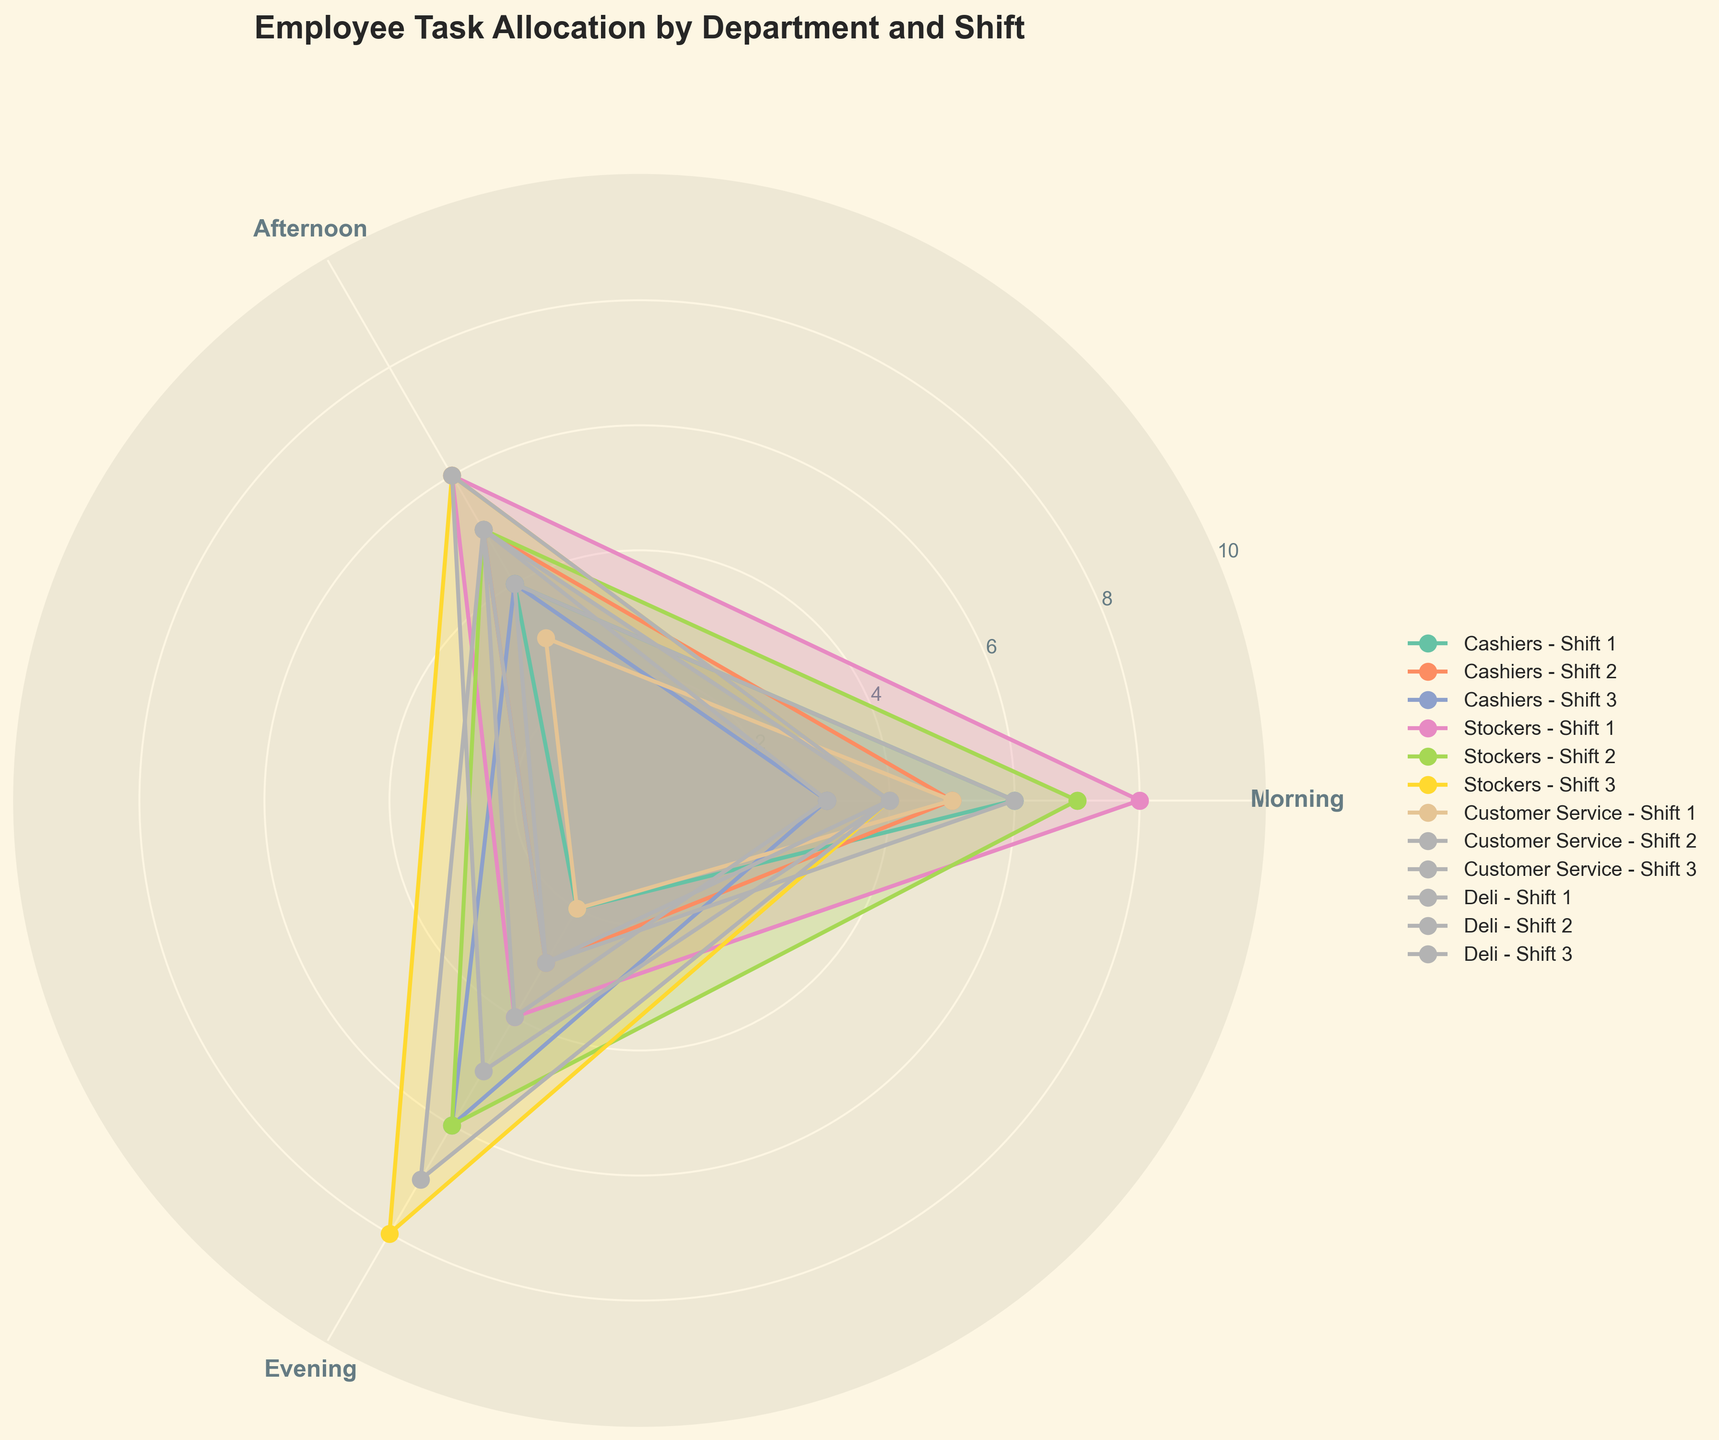what's the title of the figure? The title is located at the top of the figure and provides a succinct summary of the chart's content. It helps viewers quickly understand what the chart represents.
Answer: Employee Task Allocation by Department and Shift How many times of the day are represented in the chart? The times of the day are indicated by the number of radial lines or axes extending from the center of the polar area chart and labeled around the perimeter.
Answer: 3 Which department has the highest Morning value in Shift 1? To find the highest Morning value in Shift 1, look along the radial line labeled "Morning" and compare the values for each department color-coded by shift.
Answer: Stockers What's the total number of Morning employees across all departments in Shift 3? Sum the Morning values for all departments in Shift 3 by referring to the radial lines labeled "Morning" for Shift 3 segments. The values are Cashiers (3), Stockers (4), Customer Service (4), and Deli (4). 3 + 4 + 4 + 4 = 15
Answer: 15 Which shift has the most fluctuating values for Customer Service? Look for the Customer Service segments (color-coded) across different shifts and visually inspect which shift has the greatest variance between Morning, Afternoon, and Evening.
Answer: Shift 3 Is the Evening value of the Deli department greater in Shift 3 compared to Shift 1? Compare the Evening value of the Deli department for Shift 1 and Shift 3 by looking at the radial line labeled "Evening" for each shift.
Answer: Yes How many departments have their highest Evening value during Shift 3? For each department, find the highest Evening value and check if it corresponds to Shift 3. Verify this for Cashiers, Stockers, Customer Service, and Deli.
Answer: 4 Comparing Stockers in Shift 1, which time of day has the lowest value? For Stockers in Shift 1, compare the values for Morning, Afternoon, and Evening by looking at their respective radial lines.
Answer: Evening What is the average number of employees working in the Afternoon across all departments during Shift 2? Sum the Afternoon values for all departments in Shift 2 and divide by the number of departments. Cashiers (5), Stockers (5), Customer Service (4), and Deli (5). Average = (5 + 5 + 4 + 5) / 4 = 4.75
Answer: 4.75 